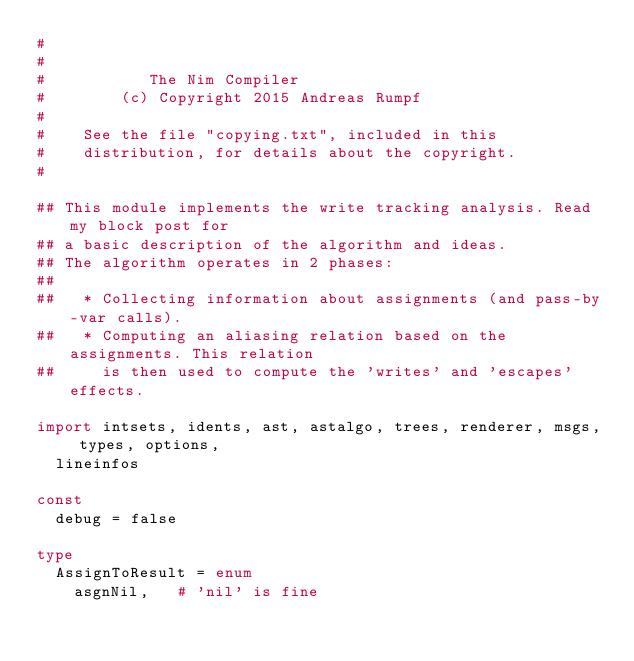<code> <loc_0><loc_0><loc_500><loc_500><_Nim_>#
#
#           The Nim Compiler
#        (c) Copyright 2015 Andreas Rumpf
#
#    See the file "copying.txt", included in this
#    distribution, for details about the copyright.
#

## This module implements the write tracking analysis. Read my block post for
## a basic description of the algorithm and ideas.
## The algorithm operates in 2 phases:
##
##   * Collecting information about assignments (and pass-by-var calls).
##   * Computing an aliasing relation based on the assignments. This relation
##     is then used to compute the 'writes' and 'escapes' effects.

import intsets, idents, ast, astalgo, trees, renderer, msgs, types, options,
  lineinfos

const
  debug = false

type
  AssignToResult = enum
    asgnNil,   # 'nil' is fine</code> 